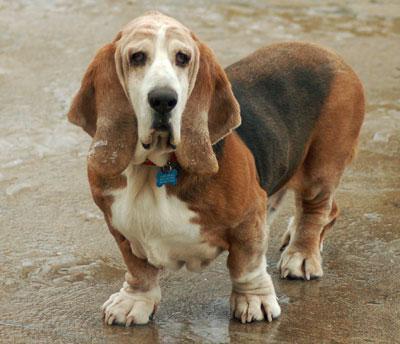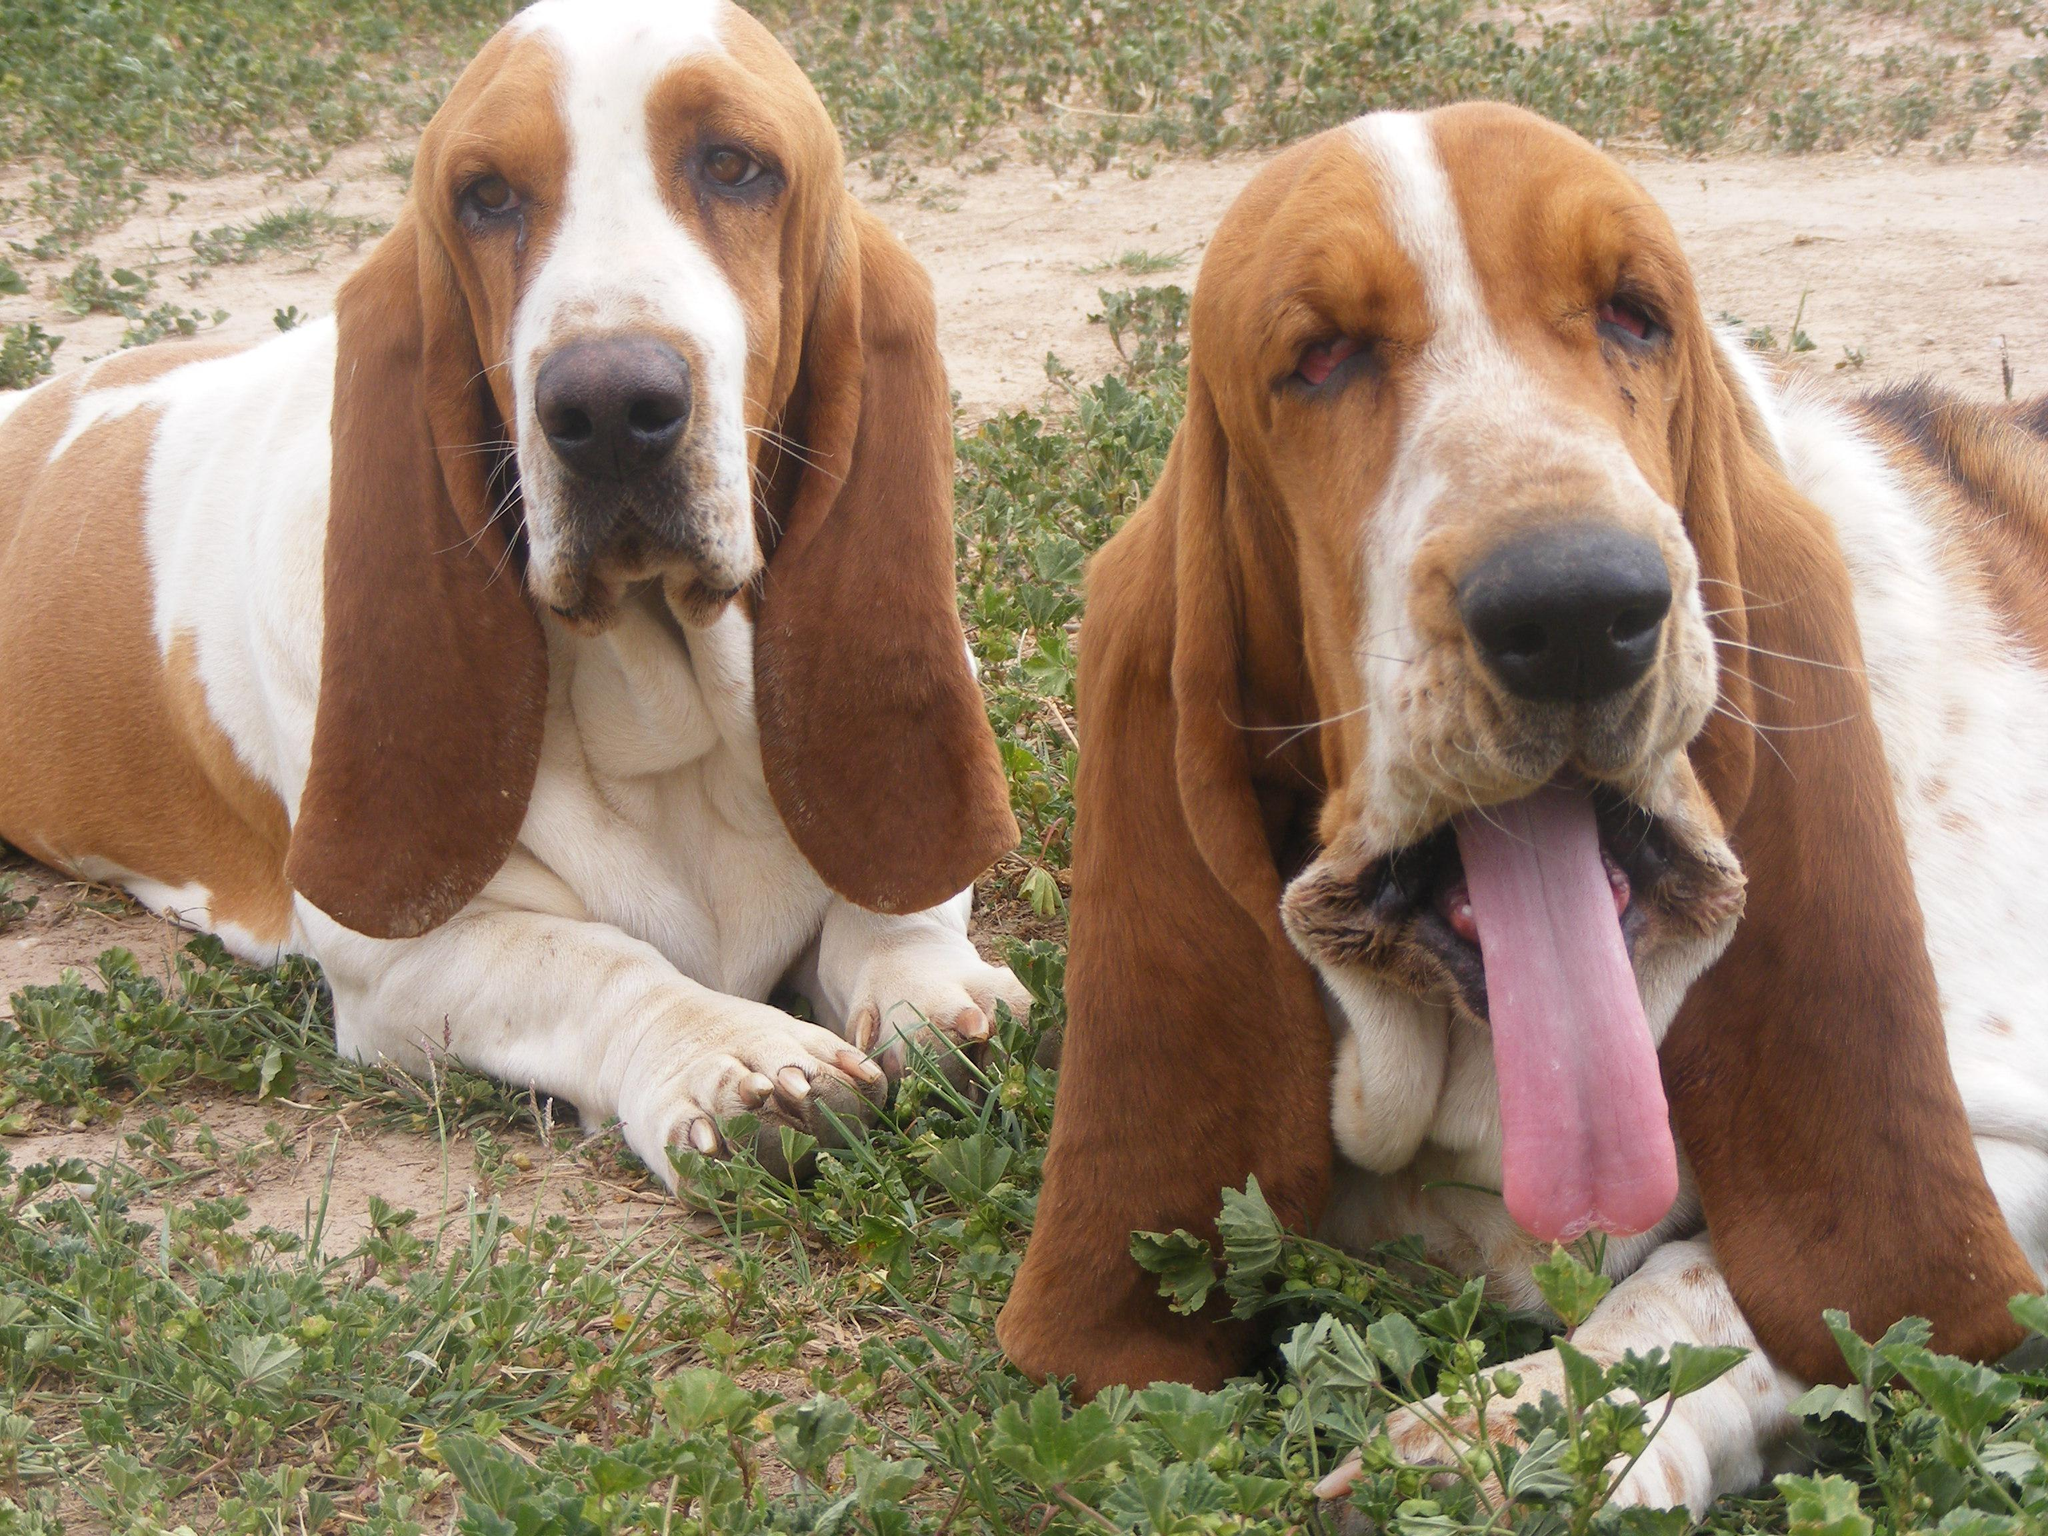The first image is the image on the left, the second image is the image on the right. Examine the images to the left and right. Is the description "There are more basset hounds in the right image than in the left." accurate? Answer yes or no. Yes. The first image is the image on the left, the second image is the image on the right. For the images displayed, is the sentence "There is one dog in the left image" factually correct? Answer yes or no. Yes. 